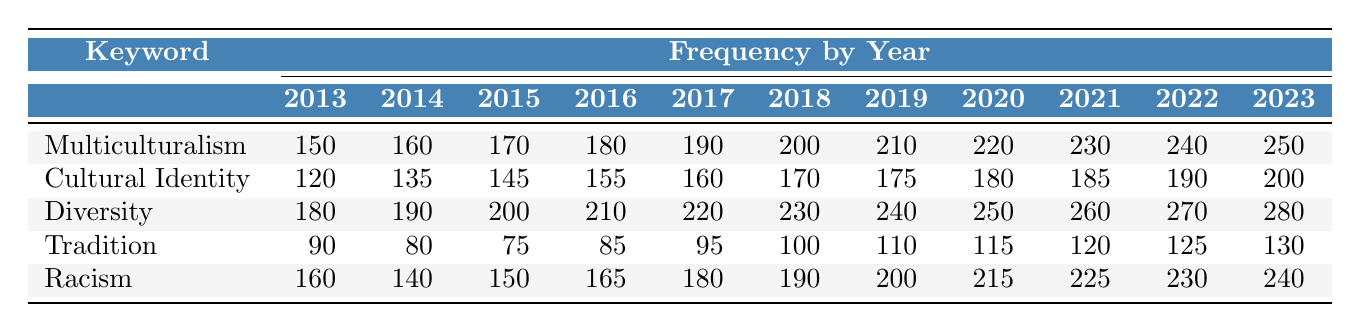What was the frequency of "Diversity" in political articles in 2020? Referring to the table, the frequency of the keyword "Diversity" in 2020 is clearly listed under that year, which shows a value of 250.
Answer: 250 In which year did "Multiculturalism" show the highest frequency? Looking at the "Multiculturalism" row, the values increase each year from 2013 to 2023. The value for 2023 is the highest at 250.
Answer: 2023 What is the total frequency of "Racism" from 2013 to 2023? To find the total frequency, we sum the values for "Racism" from each year: 160 + 140 + 150 + 165 + 180 + 190 + 200 + 215 + 225 + 230 + 240 = 1950.
Answer: 1950 Did the frequency of "Tradition" ever exceed 120 in any year? Checking the "Tradition" row, the values show that the highest frequency is 130 in 2023, which exceeds 120.
Answer: Yes What is the average frequency of "Cultural Identity" over the decade? To calculate the average, we sum the frequencies from 2013 to 2023: 120 + 135 + 145 + 155 + 160 + 170 + 175 + 180 + 185 + 190 + 200 = 1885. Then, we divide by the number of years, which is 11. The average is 1885 / 11 = 171.36.
Answer: 171.36 Which culture-related keyword had the greatest overall increase in frequency from 2013 to 2023? By examining the table, we can calculate the difference for each keyword from 2013 to 2023: "Multiculturalism" increased by 100, "Cultural Identity" by 80, "Diversity" by 100, "Tradition" by 40, and "Racism" by 80. Both "Multiculturalism" and "Diversity" show the greatest increase of 100.
Answer: Multiculturalism and Diversity 